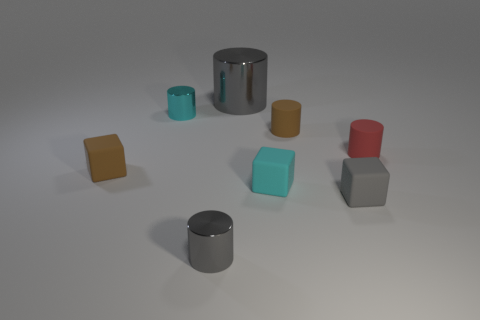Subtract all brown cubes. How many cubes are left? 2 Subtract all yellow spheres. How many gray cylinders are left? 2 Subtract all brown cylinders. How many cylinders are left? 4 Subtract 1 cylinders. How many cylinders are left? 4 Add 1 brown matte blocks. How many objects exist? 9 Subtract all blocks. How many objects are left? 5 Subtract all green cylinders. Subtract all red blocks. How many cylinders are left? 5 Add 4 gray cubes. How many gray cubes are left? 5 Add 7 small cyan balls. How many small cyan balls exist? 7 Subtract 0 red blocks. How many objects are left? 8 